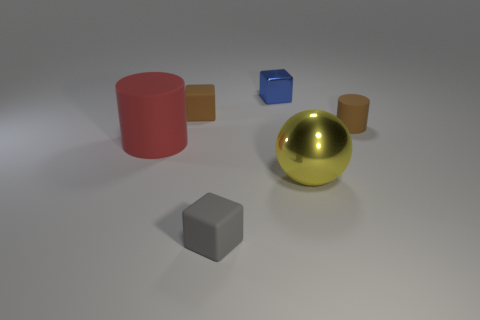Subtract all tiny rubber blocks. How many blocks are left? 1 Add 2 brown matte cylinders. How many objects exist? 8 Subtract all blue blocks. How many blocks are left? 2 Subtract all spheres. How many objects are left? 5 Subtract all red cylinders. How many blue blocks are left? 1 Subtract all big green metal cylinders. Subtract all gray blocks. How many objects are left? 5 Add 4 red rubber objects. How many red rubber objects are left? 5 Add 2 brown shiny balls. How many brown shiny balls exist? 2 Subtract 0 green cylinders. How many objects are left? 6 Subtract 1 balls. How many balls are left? 0 